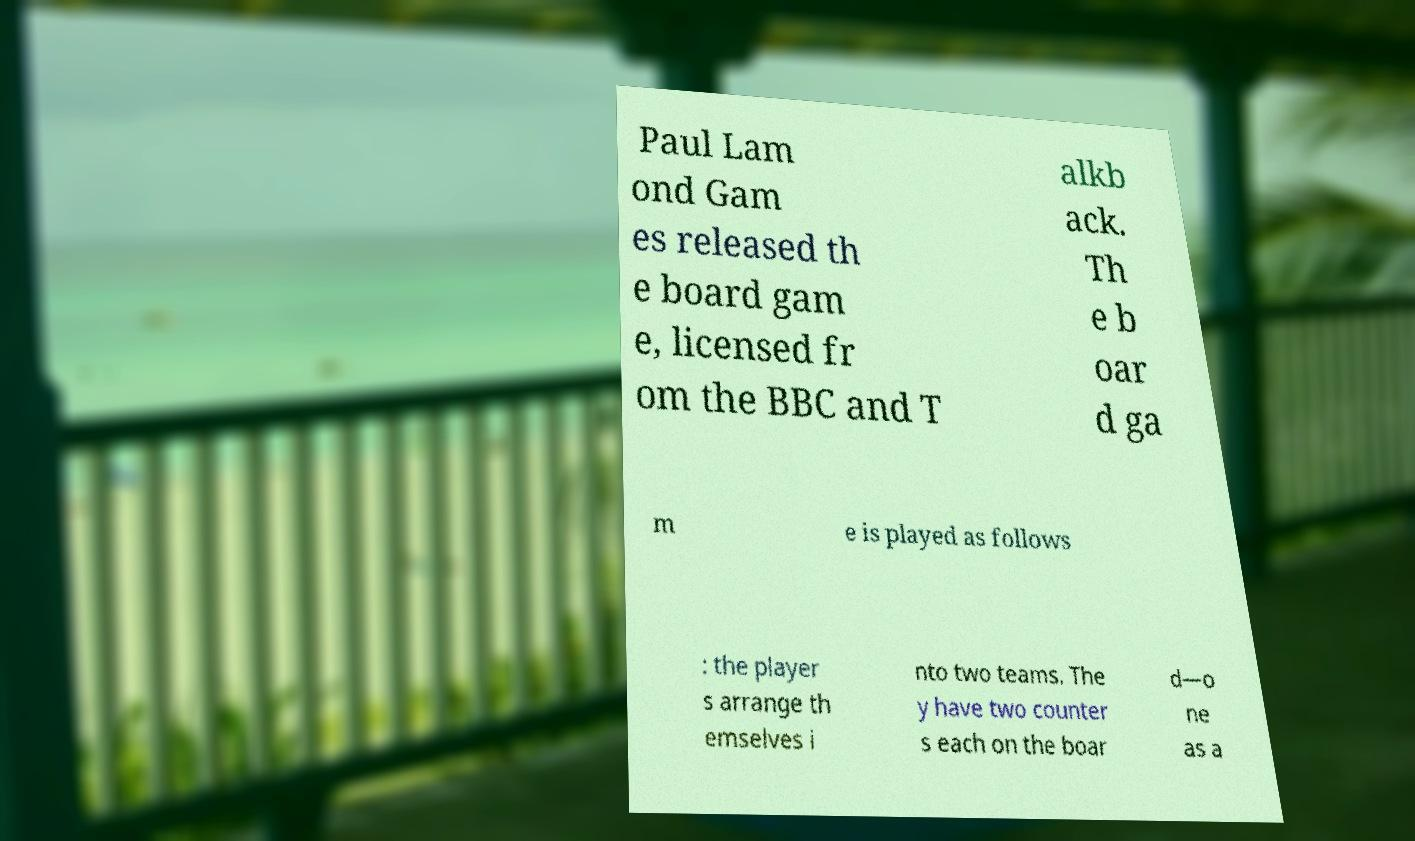Please read and relay the text visible in this image. What does it say? Paul Lam ond Gam es released th e board gam e, licensed fr om the BBC and T alkb ack. Th e b oar d ga m e is played as follows : the player s arrange th emselves i nto two teams. The y have two counter s each on the boar d—o ne as a 